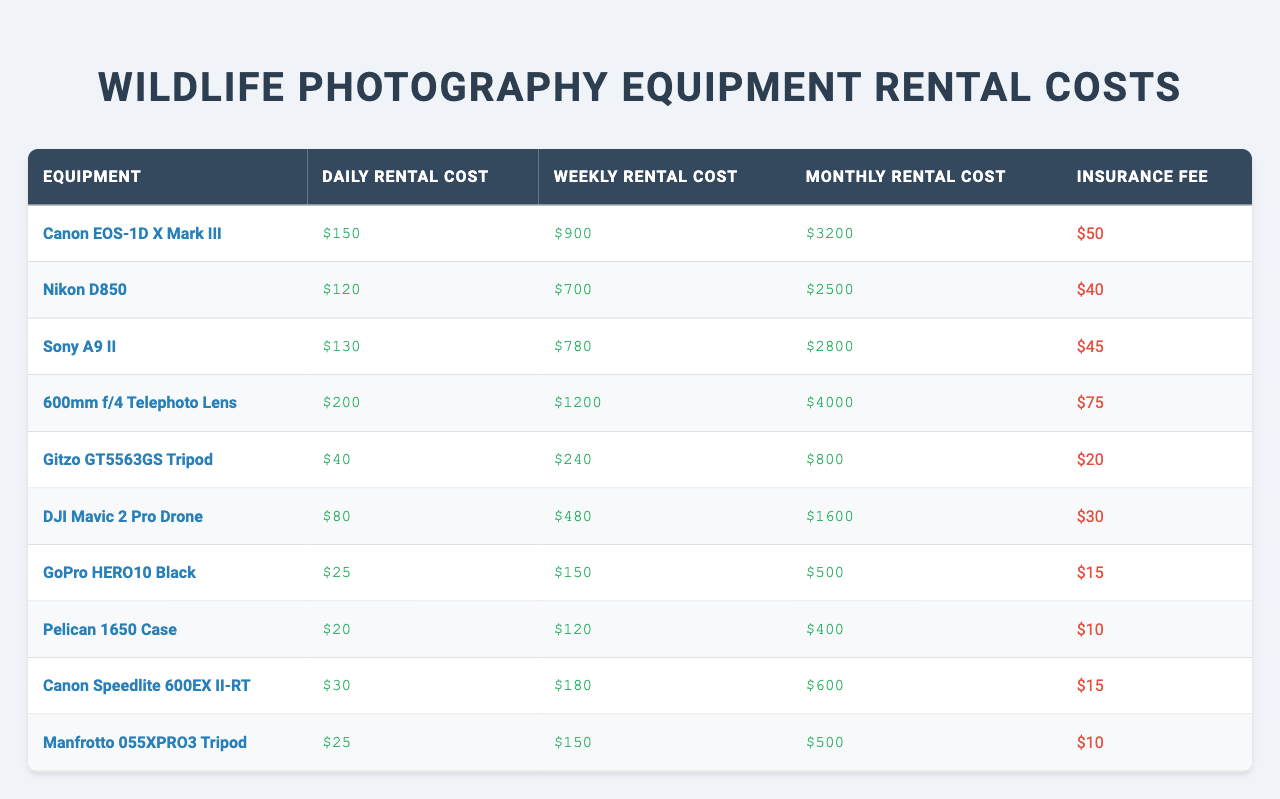What is the daily rental cost for the Canon EOS-1D X Mark III? The table lists the daily rental cost of the Canon EOS-1D X Mark III as $150.
Answer: $150 What is the weekly rental cost for the Sony A9 II? According to the table, the weekly rental cost for the Sony A9 II is $780.
Answer: $780 Which equipment has the highest insurance fee? By examining the insurance fees in the table, the 600mm f/4 Telephoto Lens has the highest fee at $75.
Answer: $75 What is the total monthly rental cost for the Nikon D850 and Canon Speedlite 600EX II-RT? The monthly costs in the table are $2500 for the Nikon D850 and $600 for the Canon Speedlite 600EX II-RT. Adding these gives $2500 + $600 = $3100.
Answer: $3100 Is the daily rental cost for the GoPro HERO10 Black higher than $30? The table shows the daily rental cost for the GoPro HERO10 Black is $25, which is less than $30.
Answer: No What is the average weekly rental cost of the tripods listed? The weekly rental costs for the Gitzo GT5563GS Tripod and Manfrotto 055XPRO3 Tripod are $240 and $150 respectively. Their average is ($240 + $150) / 2 = $195.
Answer: $195 How much more does it cost to rent the 600mm f/4 Telephoto Lens for a month compared to the DJI Mavic 2 Pro Drone? The monthly rental cost for the 600mm f/4 Telephoto Lens is $4000 and for the DJI Mavic 2 Pro Drone it is $1600. The difference is $4000 - $1600 = $2400.
Answer: $2400 What is the total insurance fee for renting all listed equipment for one expedition? The insurance fees listed in the table for each equipment are $50, $40, $45, $75, $20, $30, $15, $10, $15, and $10. Summing these gives $50 + $40 + $45 + $75 + $20 + $30 + $15 + $10 + $15 + $10 = $300.
Answer: $300 Which piece of equipment has the lowest total rental cost for a month? Examining the monthly rental costs, the Pelican 1650 Case costs $400, which is the lowest compared to other equipment.
Answer: Pelican 1650 Case Is it true that the daily rental cost of the Nikon D850 is cheaper than that of the DJI Mavic 2 Pro Drone? The daily rental cost for the Nikon D850 is $120, while the cost for the DJI Mavic 2 Pro Drone is $80, thus it is not cheaper.
Answer: No 